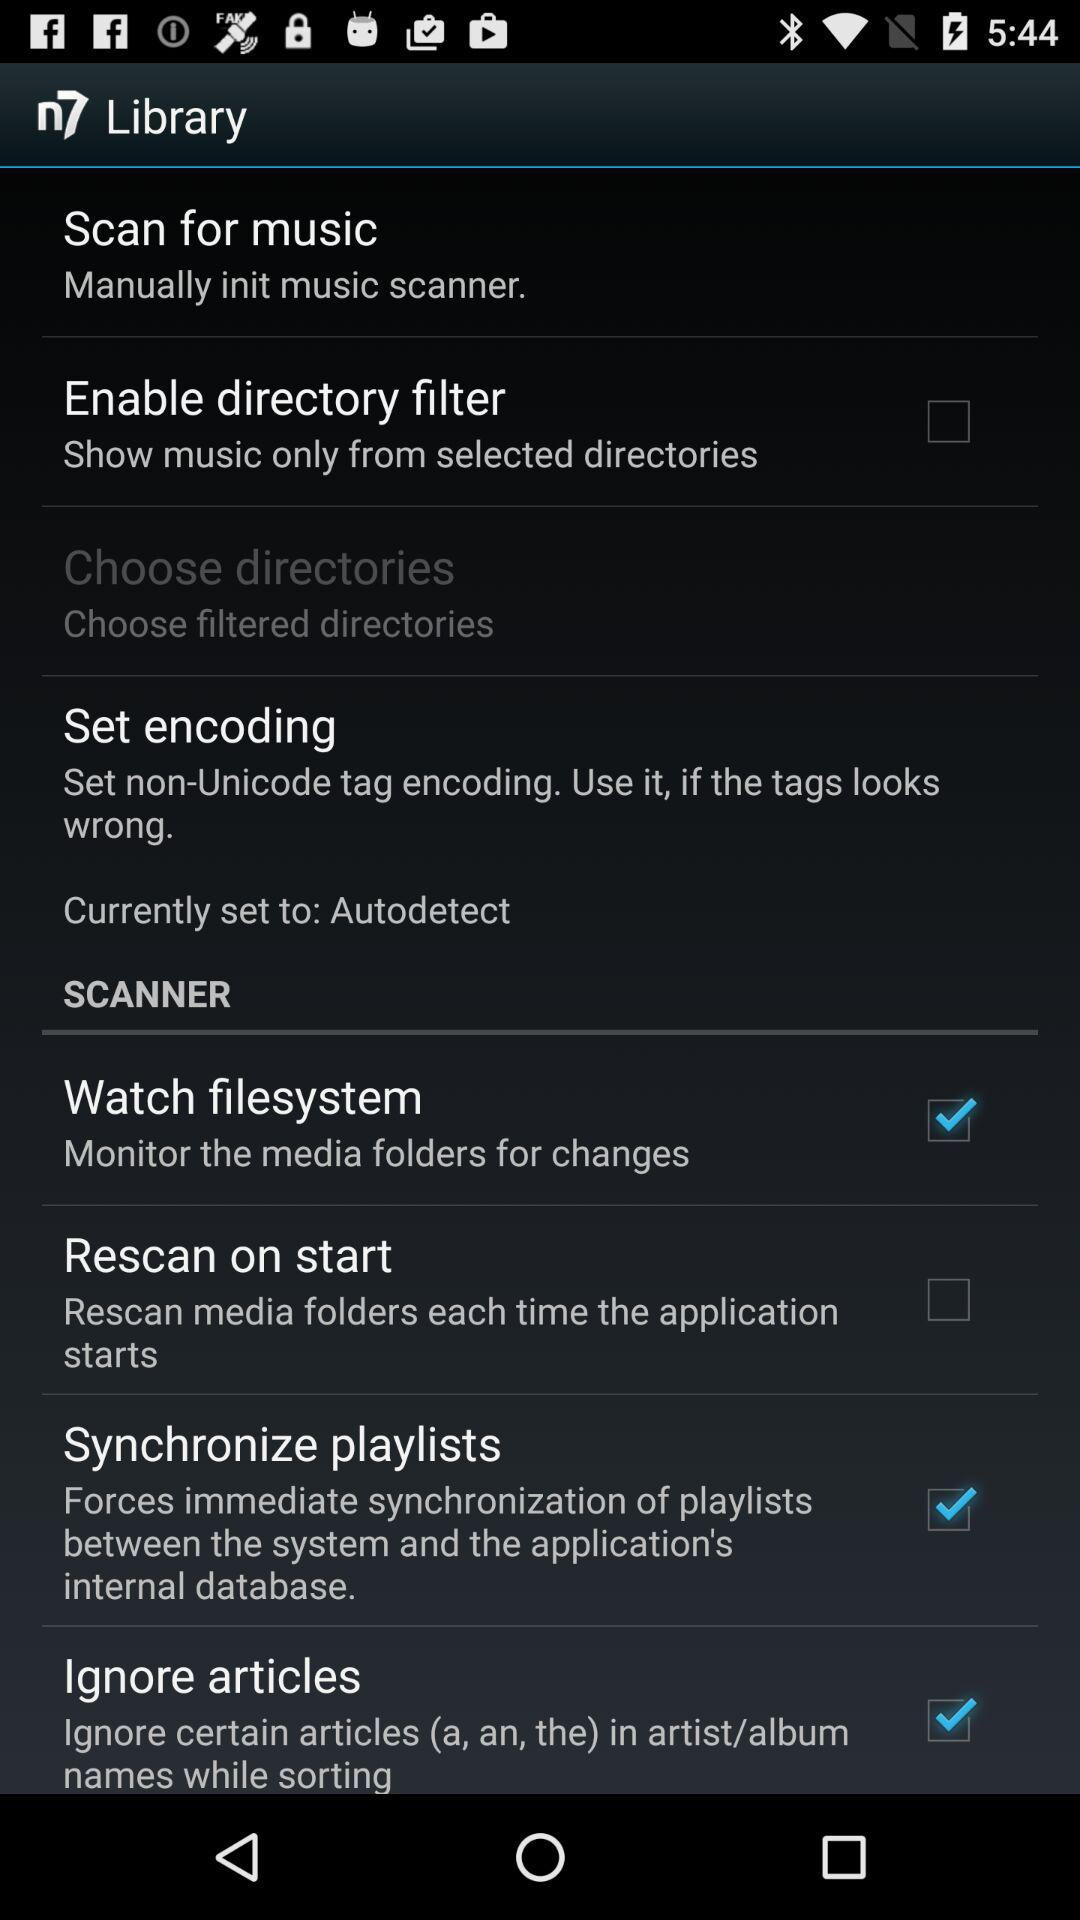What is the status of "Synchronize playlists"? The status is on. 